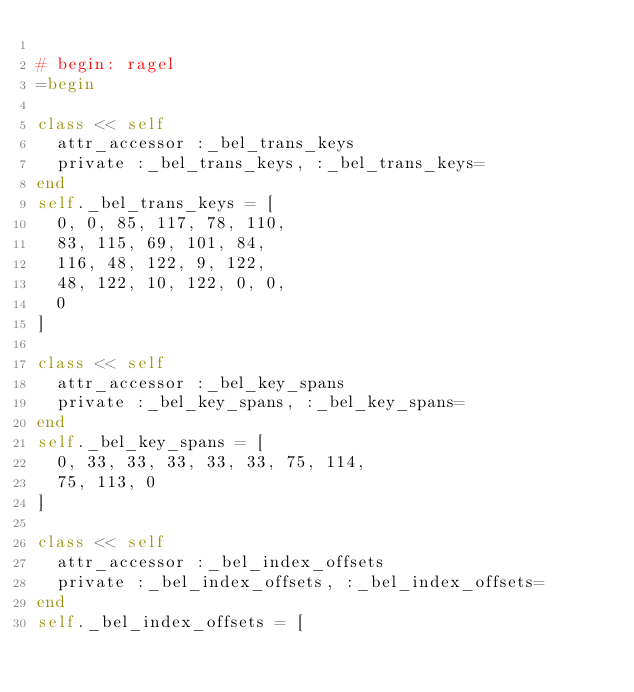<code> <loc_0><loc_0><loc_500><loc_500><_Ruby_>
# begin: ragel
=begin

class << self
	attr_accessor :_bel_trans_keys
	private :_bel_trans_keys, :_bel_trans_keys=
end
self._bel_trans_keys = [
	0, 0, 85, 117, 78, 110, 
	83, 115, 69, 101, 84, 
	116, 48, 122, 9, 122, 
	48, 122, 10, 122, 0, 0, 
	0
]

class << self
	attr_accessor :_bel_key_spans
	private :_bel_key_spans, :_bel_key_spans=
end
self._bel_key_spans = [
	0, 33, 33, 33, 33, 33, 75, 114, 
	75, 113, 0
]

class << self
	attr_accessor :_bel_index_offsets
	private :_bel_index_offsets, :_bel_index_offsets=
end
self._bel_index_offsets = [</code> 